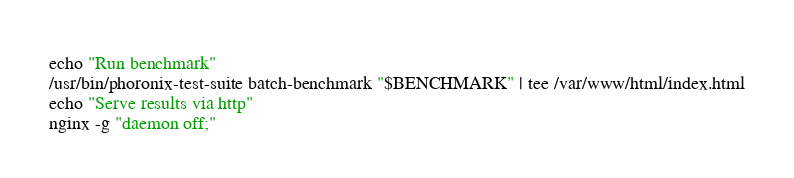<code> <loc_0><loc_0><loc_500><loc_500><_Bash_>echo "Run benchmark"
/usr/bin/phoronix-test-suite batch-benchmark "$BENCHMARK" | tee /var/www/html/index.html
echo "Serve results via http"
nginx -g "daemon off;"
</code> 